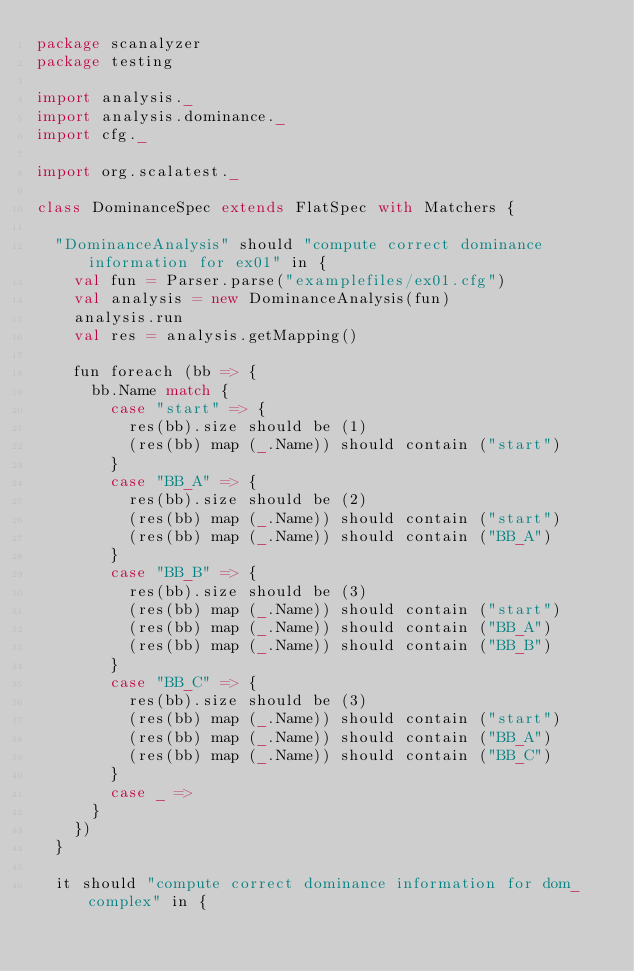<code> <loc_0><loc_0><loc_500><loc_500><_Scala_>package scanalyzer
package testing

import analysis._
import analysis.dominance._
import cfg._

import org.scalatest._

class DominanceSpec extends FlatSpec with Matchers {

  "DominanceAnalysis" should "compute correct dominance information for ex01" in {
    val fun = Parser.parse("examplefiles/ex01.cfg")
    val analysis = new DominanceAnalysis(fun)
    analysis.run
    val res = analysis.getMapping()

    fun foreach (bb => {
      bb.Name match {
        case "start" => {
          res(bb).size should be (1)
          (res(bb) map (_.Name)) should contain ("start")
        }
        case "BB_A" => {
          res(bb).size should be (2)
          (res(bb) map (_.Name)) should contain ("start")
          (res(bb) map (_.Name)) should contain ("BB_A")
        }
        case "BB_B" => {
          res(bb).size should be (3)
          (res(bb) map (_.Name)) should contain ("start")
          (res(bb) map (_.Name)) should contain ("BB_A")
          (res(bb) map (_.Name)) should contain ("BB_B")
        }
        case "BB_C" => {
          res(bb).size should be (3)
          (res(bb) map (_.Name)) should contain ("start")
          (res(bb) map (_.Name)) should contain ("BB_A")
          (res(bb) map (_.Name)) should contain ("BB_C")
        }
        case _ =>
      }
    })
  }

  it should "compute correct dominance information for dom_complex" in {</code> 